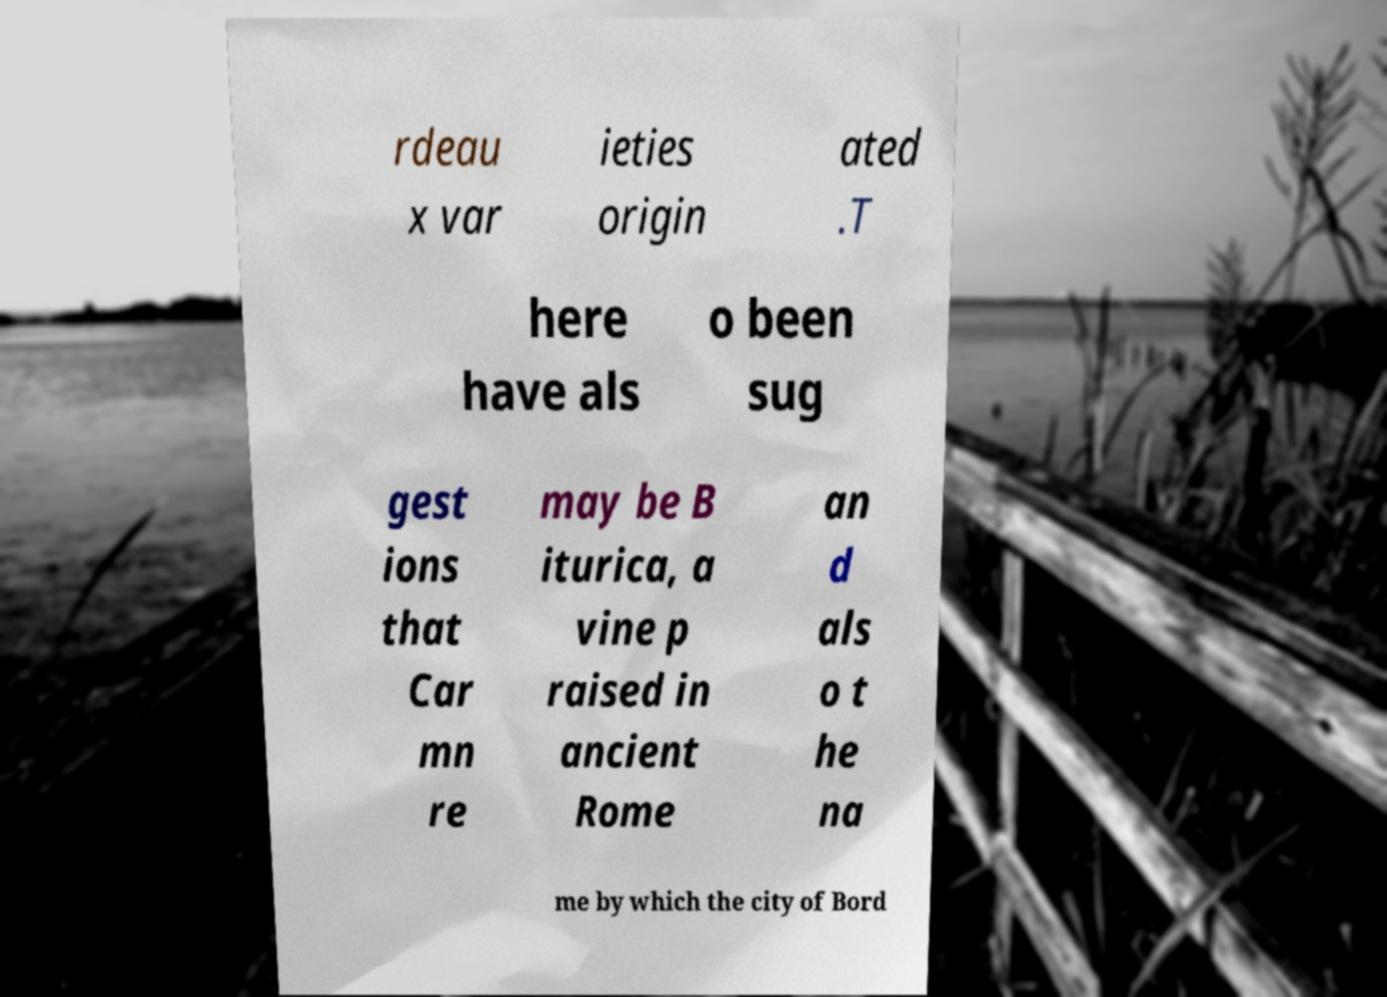What messages or text are displayed in this image? I need them in a readable, typed format. rdeau x var ieties origin ated .T here have als o been sug gest ions that Car mn re may be B iturica, a vine p raised in ancient Rome an d als o t he na me by which the city of Bord 